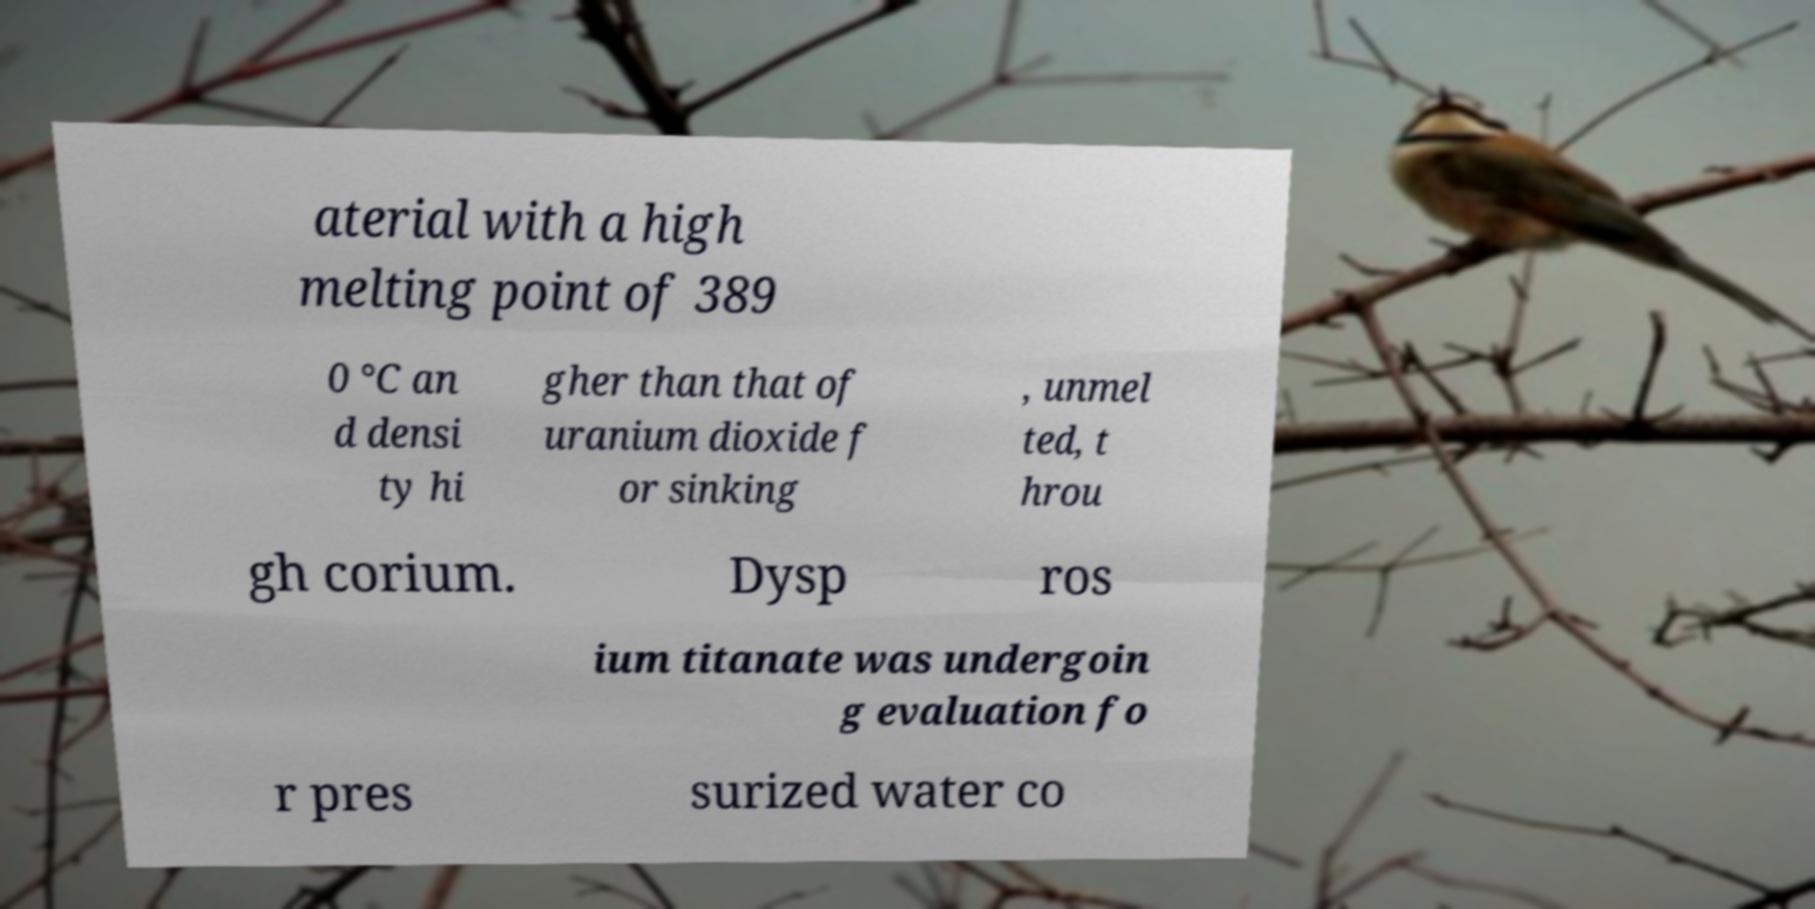There's text embedded in this image that I need extracted. Can you transcribe it verbatim? aterial with a high melting point of 389 0 °C an d densi ty hi gher than that of uranium dioxide f or sinking , unmel ted, t hrou gh corium. Dysp ros ium titanate was undergoin g evaluation fo r pres surized water co 